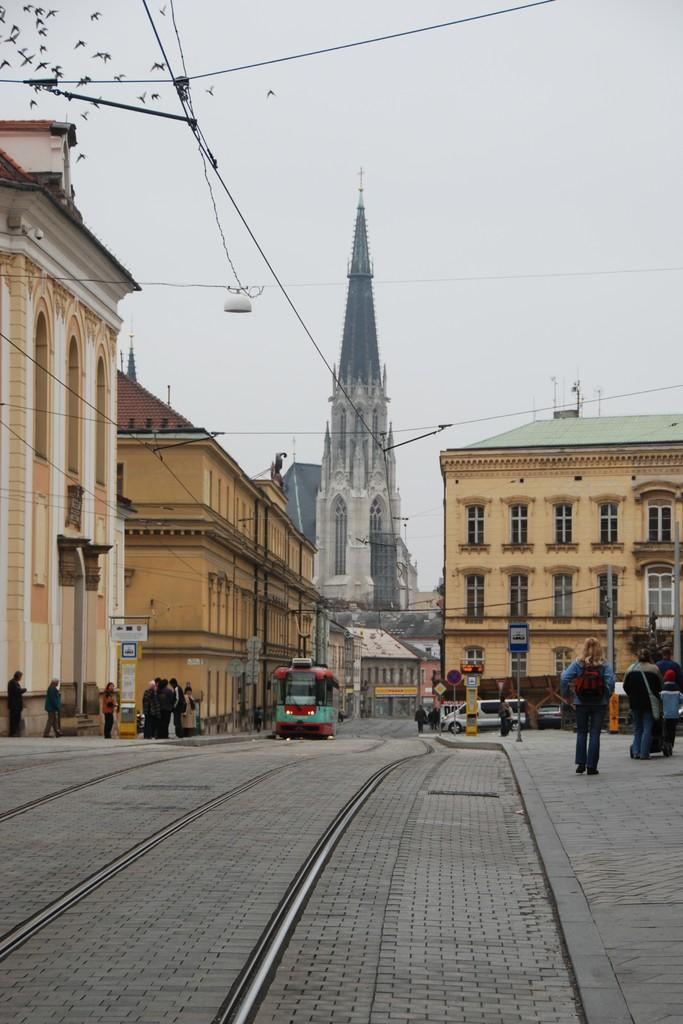What is in the foreground of the image? There is a road in the foreground of the image. Can you describe the people in the image? There are people in the image. What else can be seen in the image besides people? There are vehicles, poles, buildings, birds, and wires in the image. What is visible in the background of the image? The sky is visible in the background of the image. What type of nose can be seen on the scarecrow in the image? There is no scarecrow present in the image, so there is no nose to describe. How deep is the hole in the image? There is no hole present in the image, so its depth cannot be determined. 